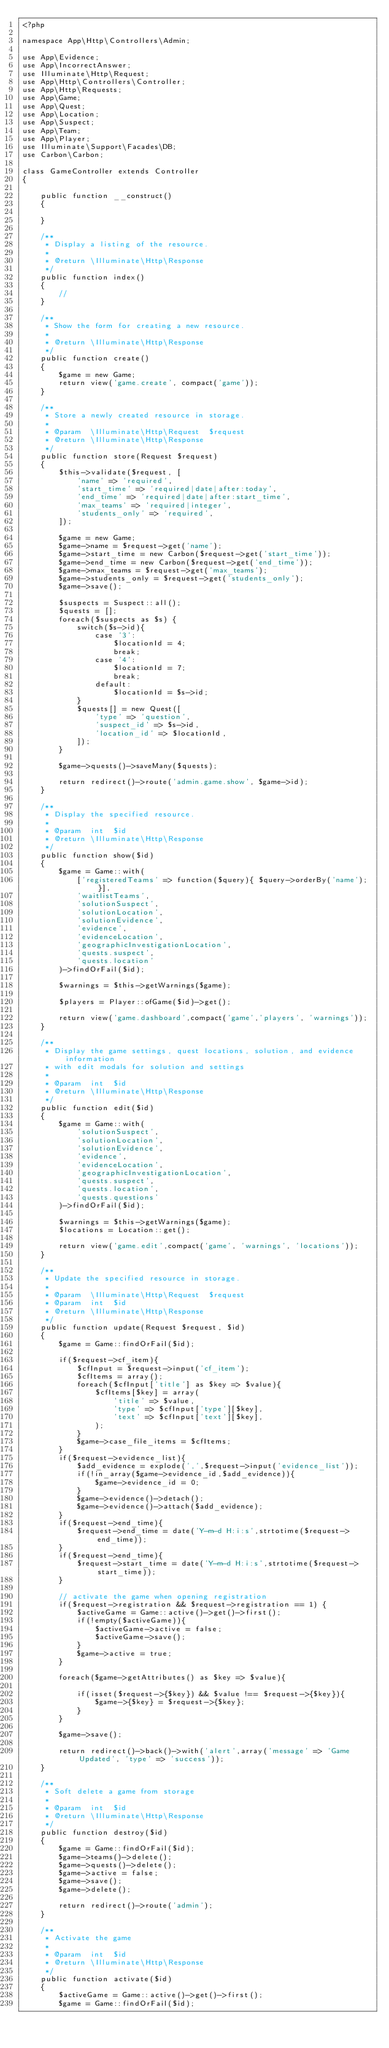Convert code to text. <code><loc_0><loc_0><loc_500><loc_500><_PHP_><?php

namespace App\Http\Controllers\Admin;

use App\Evidence;
use App\IncorrectAnswer;
use Illuminate\Http\Request;
use App\Http\Controllers\Controller;
use App\Http\Requests;
use App\Game;
use App\Quest;
use App\Location;
use App\Suspect;
use App\Team;
use App\Player;
use Illuminate\Support\Facades\DB;
use Carbon\Carbon;

class GameController extends Controller
{

    public function __construct()
    {

    }

    /**
     * Display a listing of the resource.
     *
     * @return \Illuminate\Http\Response
     */
    public function index()
    {
        //
    }

    /**
     * Show the form for creating a new resource.
     *
     * @return \Illuminate\Http\Response
     */
    public function create()
    {
        $game = new Game;
        return view('game.create', compact('game'));
    }

    /**
     * Store a newly created resource in storage.
     *
     * @param  \Illuminate\Http\Request  $request
     * @return \Illuminate\Http\Response
     */
    public function store(Request $request)
    {
        $this->validate($request, [
            'name' => 'required',
            'start_time' => 'required|date|after:today',
            'end_time' => 'required|date|after:start_time',
            'max_teams' => 'required|integer',
            'students_only' => 'required',
        ]);

        $game = new Game;
        $game->name = $request->get('name');
        $game->start_time = new Carbon($request->get('start_time'));
        $game->end_time = new Carbon($request->get('end_time'));
        $game->max_teams = $request->get('max_teams');
        $game->students_only = $request->get('students_only');
        $game->save();

        $suspects = Suspect::all();
        $quests = [];
        foreach($suspects as $s) {
            switch($s->id){
                case '3':
                    $locationId = 4;
                    break;
                case '4':
                    $locationId = 7;
                    break;
                default:
                    $locationId = $s->id;
            }
            $quests[] = new Quest([
                'type' => 'question',
                'suspect_id' => $s->id,
                'location_id' => $locationId,
            ]);
        }

        $game->quests()->saveMany($quests);

        return redirect()->route('admin.game.show', $game->id);
    }

    /**
     * Display the specified resource.
     *
     * @param  int  $id
     * @return \Illuminate\Http\Response
     */
    public function show($id)
    {
        $game = Game::with(
            ['registeredTeams' => function($query){ $query->orderBy('name'); }],
            'waitlistTeams',
            'solutionSuspect',
            'solutionLocation',
            'solutionEvidence',
            'evidence',
            'evidenceLocation',
            'geographicInvestigationLocation',
            'quests.suspect',
            'quests.location'
        )->findOrFail($id);

        $warnings = $this->getWarnings($game);

        $players = Player::ofGame($id)->get();

        return view('game.dashboard',compact('game','players', 'warnings'));
    }

    /**
     * Display the game settings, quest locations, solution, and evidence information
     * with edit modals for solution and settings
     *
     * @param  int  $id
     * @return \Illuminate\Http\Response
     */
    public function edit($id)
    {
        $game = Game::with(
            'solutionSuspect',
            'solutionLocation',
            'solutionEvidence',
            'evidence',
            'evidenceLocation',
            'geographicInvestigationLocation',
            'quests.suspect',
            'quests.location',
            'quests.questions'
        )->findOrFail($id);

        $warnings = $this->getWarnings($game);
        $locations = Location::get();

        return view('game.edit',compact('game', 'warnings', 'locations'));
    }

    /**
     * Update the specified resource in storage.
     *
     * @param  \Illuminate\Http\Request  $request
     * @param  int  $id
     * @return \Illuminate\Http\Response
     */
    public function update(Request $request, $id)
    {
        $game = Game::findOrFail($id);

        if($request->cf_item){
            $cfInput = $request->input('cf_item');
            $cfItems = array();
            foreach($cfInput['title'] as $key => $value){
                $cfItems[$key] = array(
                    'title' => $value,
                    'type' => $cfInput['type'][$key],
                    'text' => $cfInput['text'][$key],
                );
            }
            $game->case_file_items = $cfItems;
        }
        if($request->evidence_list){
            $add_evidence = explode(',',$request->input('evidence_list'));
            if(!in_array($game->evidence_id,$add_evidence)){
                $game->evidence_id = 0;
            }
            $game->evidence()->detach();
            $game->evidence()->attach($add_evidence);
        }
        if($request->end_time){
            $request->end_time = date('Y-m-d H:i:s',strtotime($request->end_time));
        }
        if($request->end_time){
            $request->start_time = date('Y-m-d H:i:s',strtotime($request->start_time));
        }

        // activate the game when opening registration
        if($request->registration && $request->registration == 1) {
            $activeGame = Game::active()->get()->first();
            if(!empty($activeGame)){
                $activeGame->active = false;
                $activeGame->save();
            }
            $game->active = true;
        }

        foreach($game->getAttributes() as $key => $value){

            if(isset($request->{$key}) && $value !== $request->{$key}){
                $game->{$key} = $request->{$key};
            }
        }

        $game->save();

        return redirect()->back()->with('alert',array('message' => 'Game Updated', 'type' => 'success'));
    }

    /**
     * Soft delete a game from storage
     *
     * @param  int  $id
     * @return \Illuminate\Http\Response
     */
    public function destroy($id)
    {
        $game = Game::findOrFail($id);
        $game->teams()->delete();
        $game->quests()->delete();
        $game->active = false;
        $game->save();
        $game->delete();

        return redirect()->route('admin');
    }

    /**
     * Activate the game
     *
     * @param  int  $id
     * @return \Illuminate\Http\Response
     */
    public function activate($id)
    {
        $activeGame = Game::active()->get()->first();
        $game = Game::findOrFail($id);
</code> 